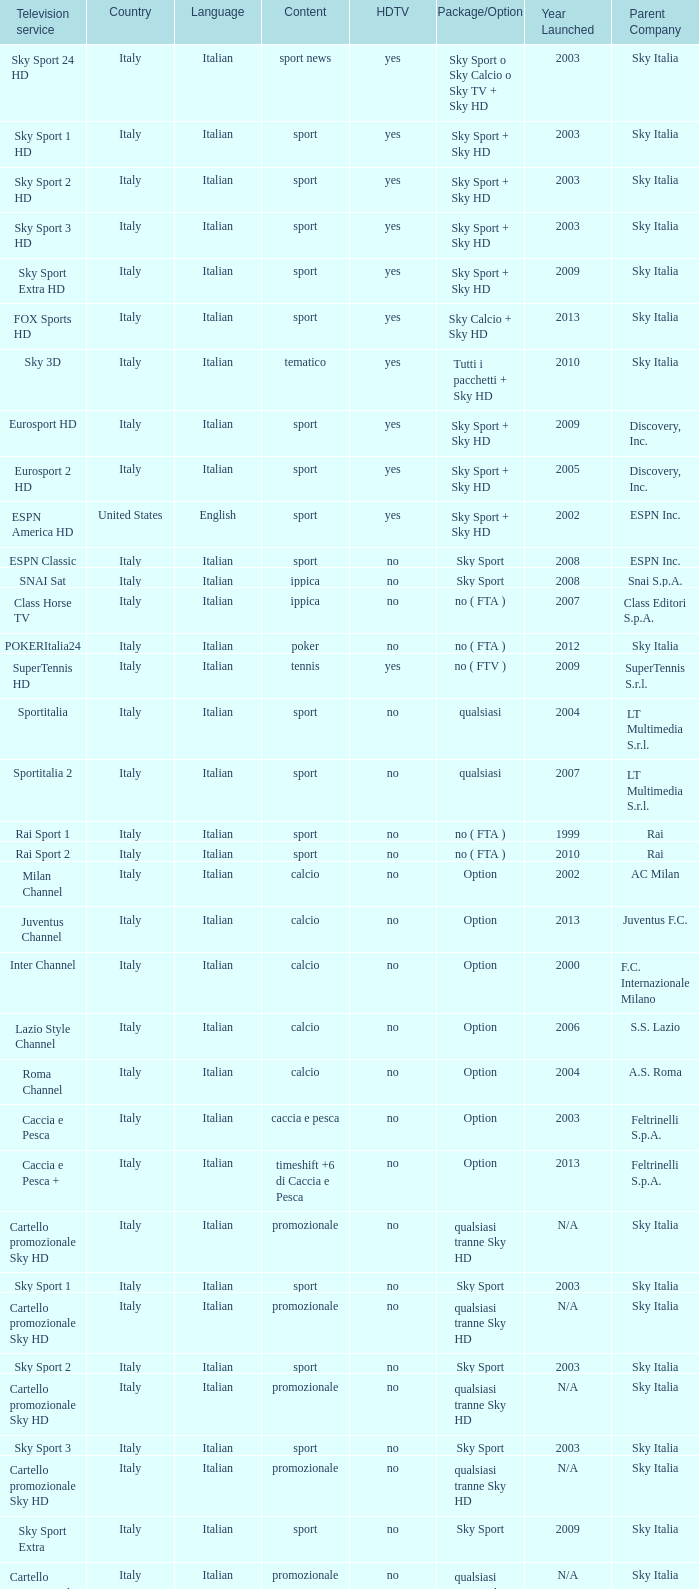What is speech, when subject is athletics, when high-definition tv is no, and when tv service is espn america? Italian. 